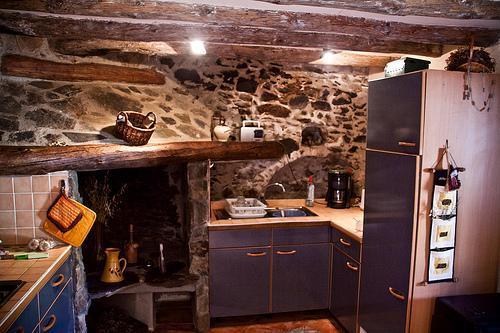How many people are pictured here?
Give a very brief answer. 0. How many wooden handles can be seen?
Give a very brief answer. 8. 